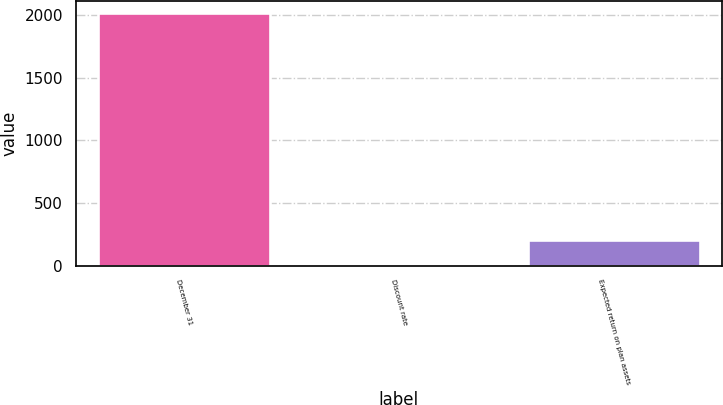Convert chart. <chart><loc_0><loc_0><loc_500><loc_500><bar_chart><fcel>December 31<fcel>Discount rate<fcel>Expected return on plan assets<nl><fcel>2016<fcel>4.86<fcel>205.97<nl></chart> 